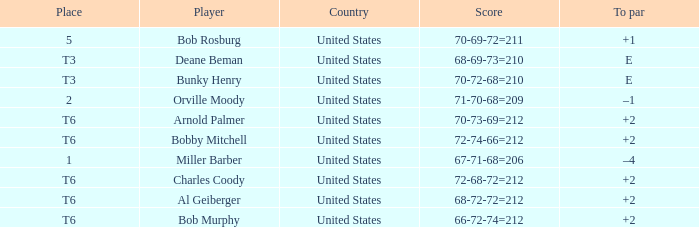Who is the player with a t6 place and a 72-68-72=212 score? Charles Coody. 